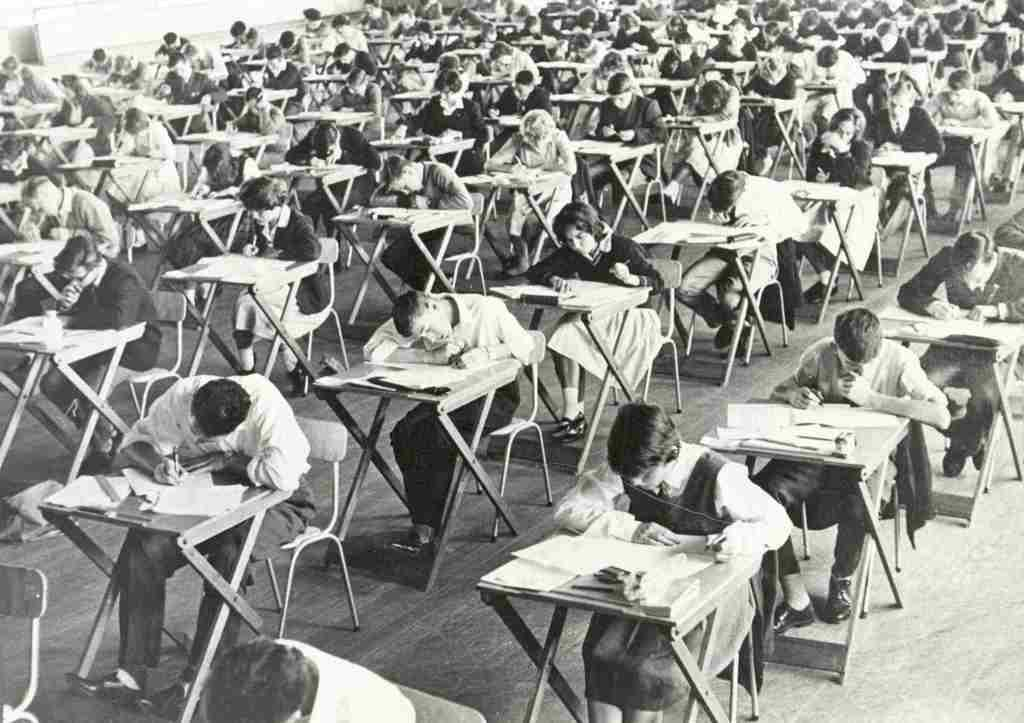How many people are present in the room? There are many people in the room. What are some people doing in the room? Some people are sitting in chairs. What activity are the people engaged in while sitting in chairs? People are writing on papers on the tables. What type of throne can be seen in the room? There is no throne present in the room; it is a room with many people and tables. Are there any birds visible in the room? There is no mention of birds in the provided facts, so it cannot be determined if any are present in the room. 